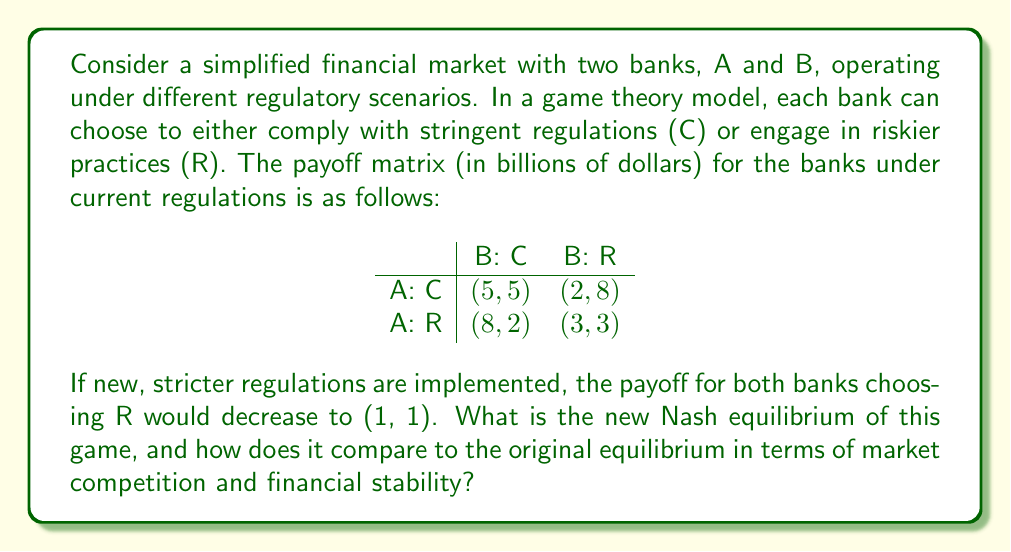Can you answer this question? To solve this problem, we need to follow these steps:

1. Identify the Nash equilibrium in the original game.
2. Determine the new payoff matrix after the regulation change.
3. Find the Nash equilibrium in the new game.
4. Compare the equilibria and discuss their implications for market competition and financial stability.

Step 1: Original Nash Equilibrium
In the original game, we can see that (R, R) is the Nash equilibrium. This is because:
- If A chooses C, B's best response is R (8 > 5)
- If A chooses R, B's best response is R (3 > 2)
- If B chooses C, A's best response is R (8 > 5)
- If B chooses R, A's best response is R (3 > 2)

Therefore, neither bank has an incentive to unilaterally deviate from (R, R).

Step 2: New Payoff Matrix
After the regulation change, the new payoff matrix becomes:

$$
\begin{array}{c|cc}
 & \text{B: C} & \text{B: R} \\
\hline
\text{A: C} & (5, 5) & (2, 8) \\
\text{A: R} & (8, 2) & (1, 1)
\end{array}
$$

Step 3: New Nash Equilibrium
In the new game:
- If A chooses C, B's best response is R (8 > 5)
- If A chooses R, B's best response is C (2 > 1)
- If B chooses C, A's best response is R (8 > 5)
- If B chooses R, A's best response is C (2 > 1)

We can see that there is no pure strategy Nash equilibrium in this new game. Instead, we need to find a mixed strategy equilibrium.

Let $p$ be the probability that A chooses C, and $q$ be the probability that B chooses C.

For A to be indifferent between C and R:
$5q + 2(1-q) = 8q + 1(1-q)$
$3q + 2 = 7q + 1$
$1 = 4q$
$q = 1/4$

For B to be indifferent between C and R:
$5p + 2(1-p) = 8p + 1(1-p)$
$3p + 2 = 7p + 1$
$1 = 4p$
$p = 1/4$

Therefore, the mixed strategy Nash equilibrium is (1/4 C + 3/4 R, 1/4 C + 3/4 R).

Step 4: Comparison and Implications
Original equilibrium: (R, R) with payoffs (3, 3)
New equilibrium: Mixed strategy (1/4 C + 3/4 R, 1/4 C + 3/4 R)

Expected payoff in the new equilibrium:
$E = (1/4 * 1/4 * 5) + (1/4 * 3/4 * 2) + (3/4 * 1/4 * 8) + (3/4 * 3/4 * 1) = 2.8125$

The new regulations have led to a more balanced market where banks sometimes comply with regulations. This increases financial stability compared to the original equilibrium where both banks always chose risky practices. However, the expected payoff is slightly lower (2.8125 vs 3), which might indicate a small reduction in market efficiency or profitability.

The mixed strategy also introduces more uncertainty in the market, as banks are now less predictable in their behavior. This could lead to a more dynamic and potentially more competitive market environment, as banks must constantly adapt to each other's strategies.
Answer: The new Nash equilibrium is a mixed strategy where both banks choose to comply (C) with probability 1/4 and engage in risky practices (R) with probability 3/4. This equilibrium leads to increased financial stability and potentially more dynamic market competition compared to the original (R, R) equilibrium, albeit with a slightly lower expected payoff of 2.8125 billion dollars for each bank. 